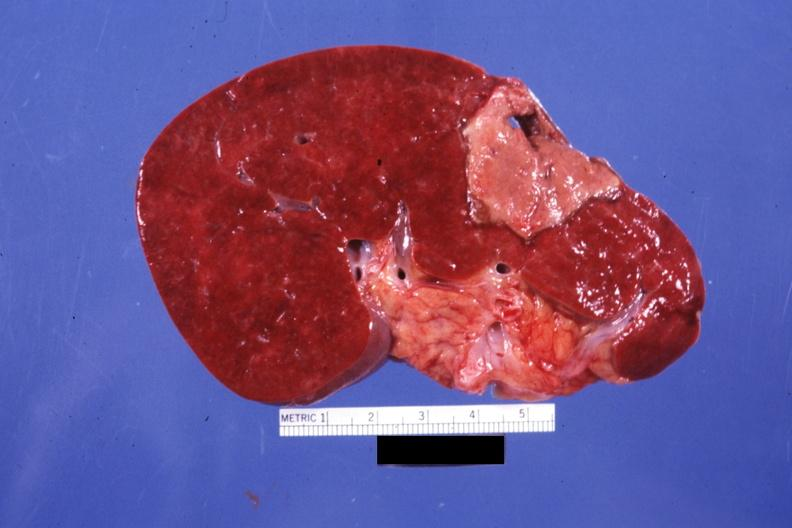does this image show large and typically shaped old infarct but far from fibrotic?
Answer the question using a single word or phrase. Yes 